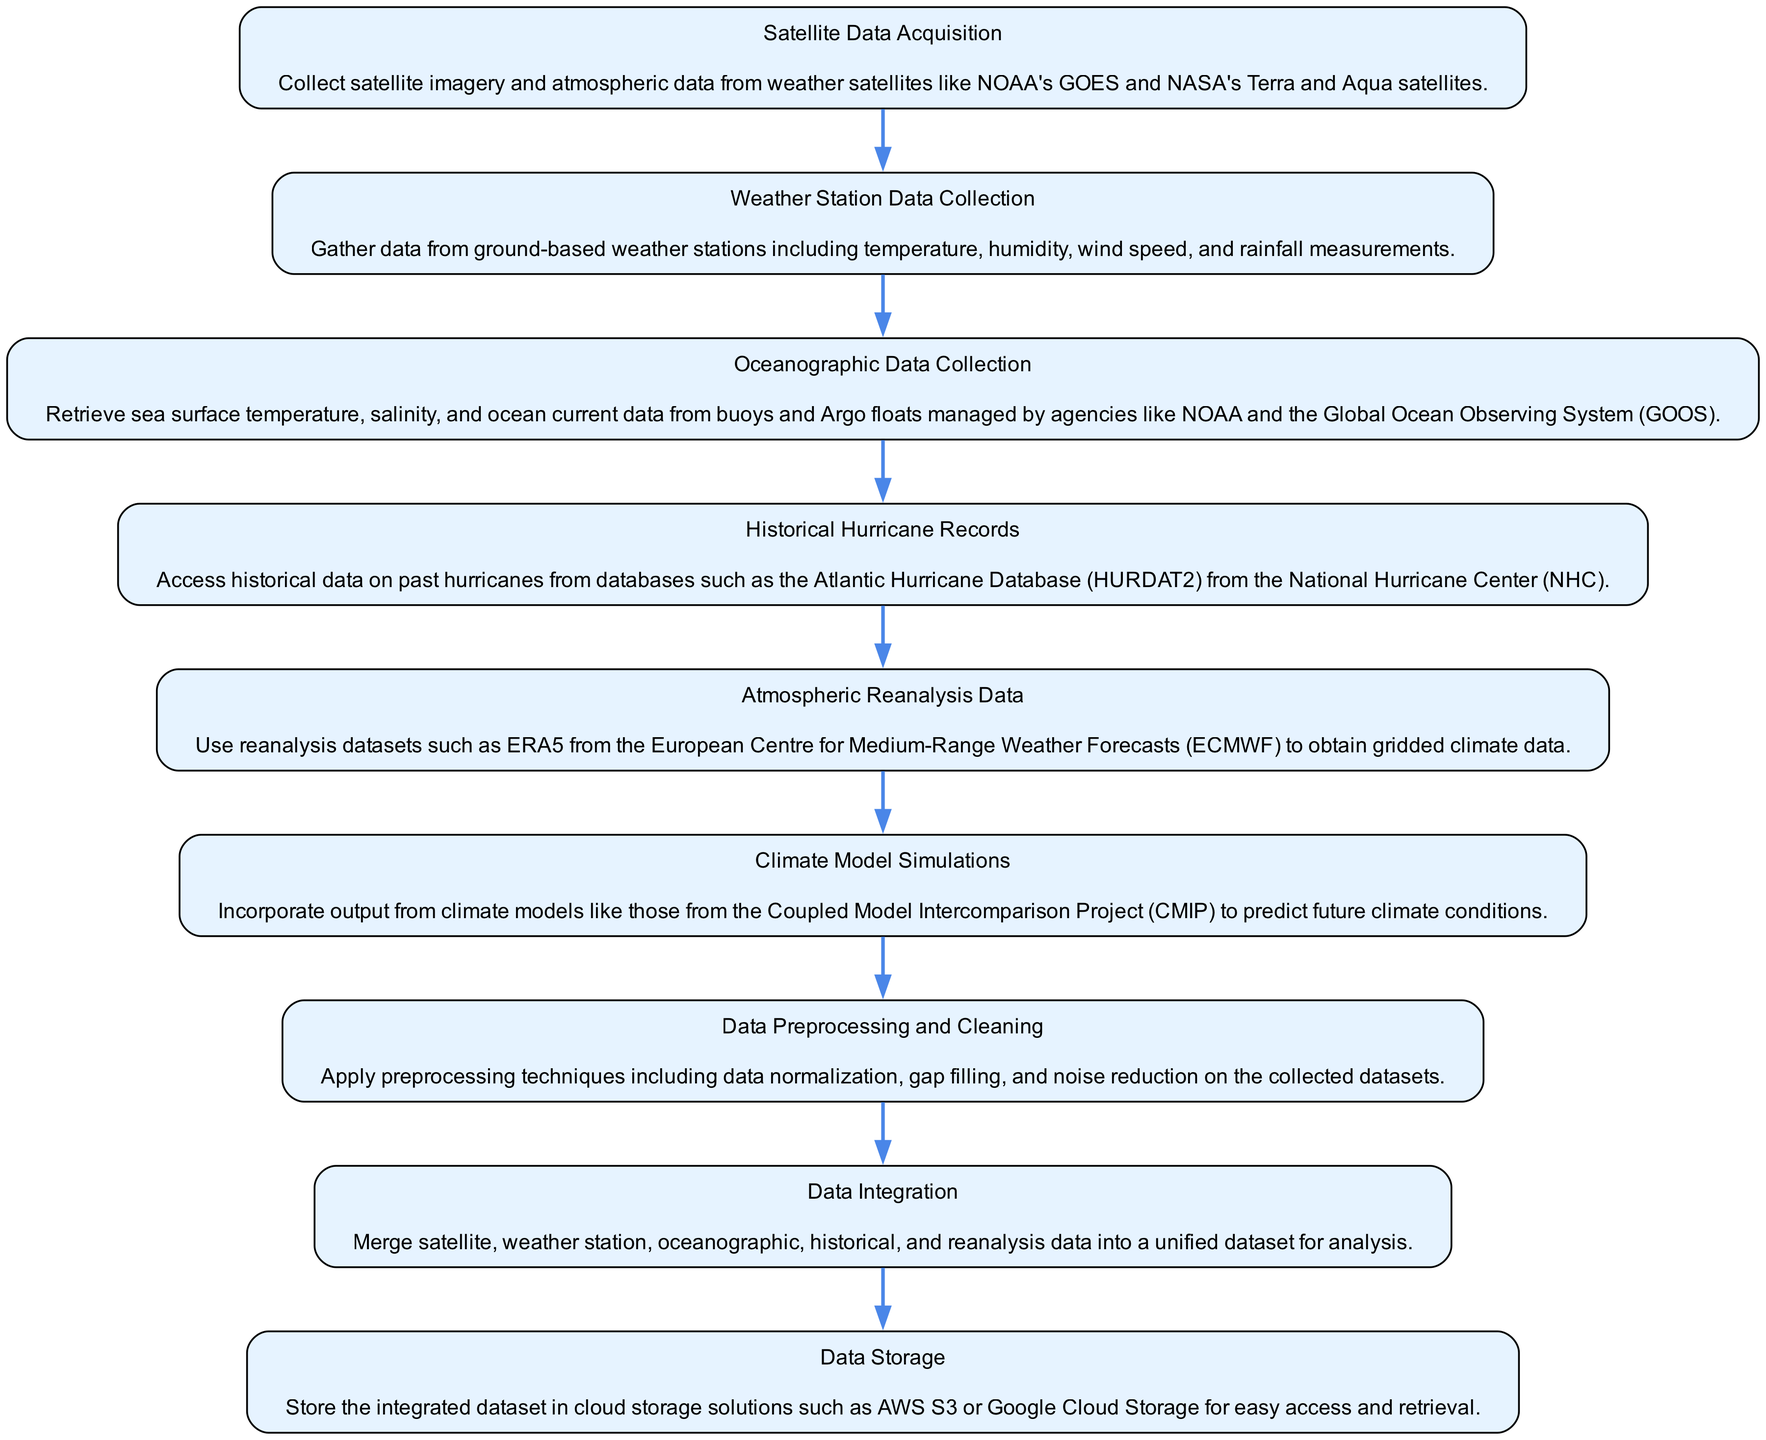What is the first step in the data collection process? The first step listed in the diagram is "Satellite Data Acquisition," which is the initial process in the flow chart.
Answer: Satellite Data Acquisition How many processes are there in total? By counting the individual processes outlined in the diagram, we find there are nine processes mentioned.
Answer: Nine What follows after "Oceanographic Data Collection"? In the flow of the diagram, the process that comes after "Oceanographic Data Collection" is "Historical Hurricane Records."
Answer: Historical Hurricane Records Which process is the last in the data collection flow? The last process in the diagram is "Data Storage," which is the final step listed.
Answer: Data Storage What type of data is collected in "Weather Station Data Collection"? The data collected in this step includes temperature, humidity, wind speed, and rainfall measurements as described in the diagram.
Answer: Temperature, humidity, wind speed, rainfall Explain the relationship between "Data Integration" and "Data Preprocessing and Cleaning." "Data Preprocessing and Cleaning" is the step before "Data Integration" in the diagram, indicating that the collected datasets must be preprocessed before they can be integrated into a unified dataset for analysis.
Answer: Data preprocessing comes before data integration Which process uses reanalysis datasets? The process that utilizes reanalysis datasets is "Atmospheric Reanalysis Data."
Answer: Atmospheric Reanalysis Data How does "Climate Model Simulations" relate to predicting future climate conditions? "Climate Model Simulations" incorporates output from climate models to make predictions about future climate conditions, showing a direct relationship between this process and forecasting.
Answer: Predicts future climate conditions What is the purpose of "Data Storage" in the collection process? The purpose of "Data Storage" is to ensure that the integrated dataset is stored in cloud solutions like AWS or Google Cloud, allowing for easy access and retrieval.
Answer: Easy access and retrieval 